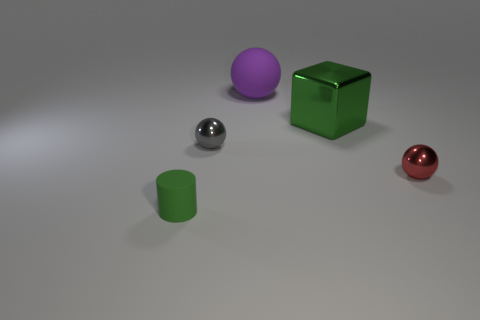There is a matte object that is to the right of the tiny matte cylinder; what is its shape?
Make the answer very short. Sphere. There is a green object that is the same size as the gray object; what material is it?
Your response must be concise. Rubber. What number of things are either red objects on the right side of the large rubber thing or objects behind the cylinder?
Provide a short and direct response. 4. The ball that is the same material as the gray thing is what size?
Keep it short and to the point. Small. How many metal objects are large objects or tiny cubes?
Make the answer very short. 1. What size is the purple matte object?
Keep it short and to the point. Large. Is the purple matte thing the same size as the green shiny cube?
Make the answer very short. Yes. There is a big object that is on the right side of the big purple rubber ball; what is it made of?
Ensure brevity in your answer.  Metal. There is a gray object that is the same shape as the big purple rubber object; what material is it?
Your answer should be compact. Metal. There is a shiny object to the left of the green shiny object; is there a green thing to the right of it?
Ensure brevity in your answer.  Yes. 